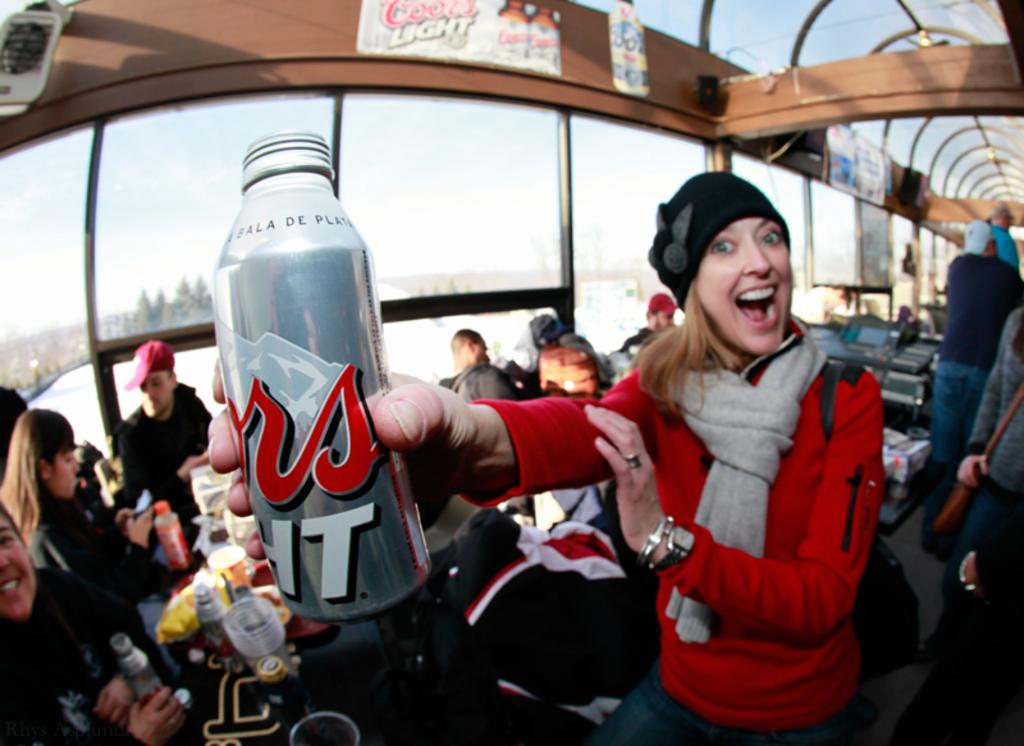Who is the main subject in the image? There is a woman in the image. What is the woman doing in the image? The woman is posing for the camera. What is the woman holding in her hand? The woman is holding a container in her hand. What can be seen in the background of the image? There are people sitting at tables in the background of the image. What type of guide is the woman holding in her hand? The woman is not holding a guide in her hand; she is holding a container. What color are the woman's lips in the image? The provided facts do not mention the color of the woman's lips, so we cannot determine that information from the image. 